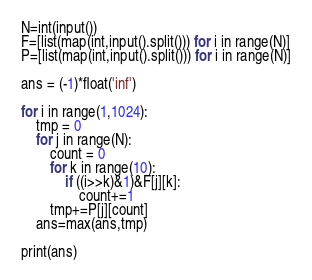Convert code to text. <code><loc_0><loc_0><loc_500><loc_500><_Python_>N=int(input())
F=[list(map(int,input().split())) for i in range(N)]
P=[list(map(int,input().split())) for i in range(N)]

ans = (-1)*float('inf')

for i in range(1,1024):
    tmp = 0
    for j in range(N):
        count = 0
        for k in range(10):
            if ((i>>k)&1)&F[j][k]:
                count+=1
        tmp+=P[j][count]
    ans=max(ans,tmp)

print(ans)</code> 